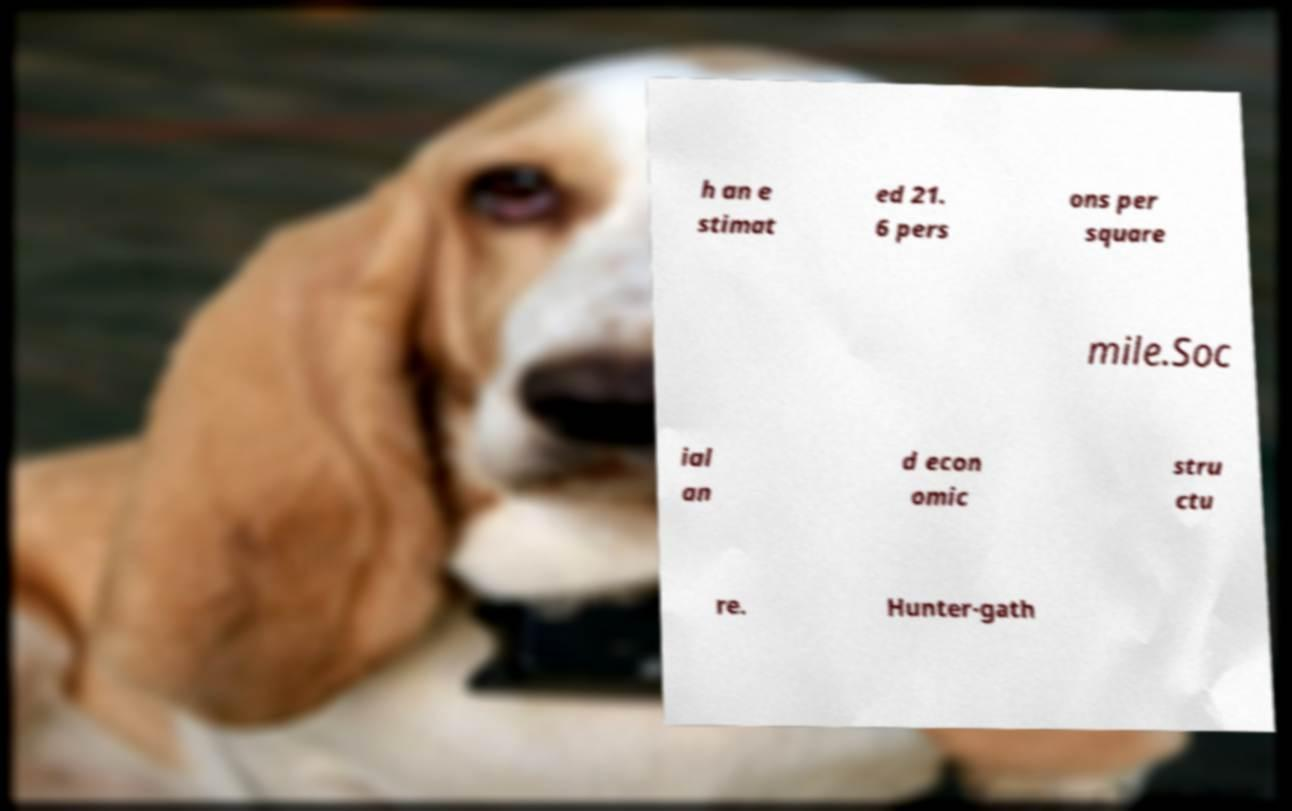There's text embedded in this image that I need extracted. Can you transcribe it verbatim? h an e stimat ed 21. 6 pers ons per square mile.Soc ial an d econ omic stru ctu re. Hunter-gath 